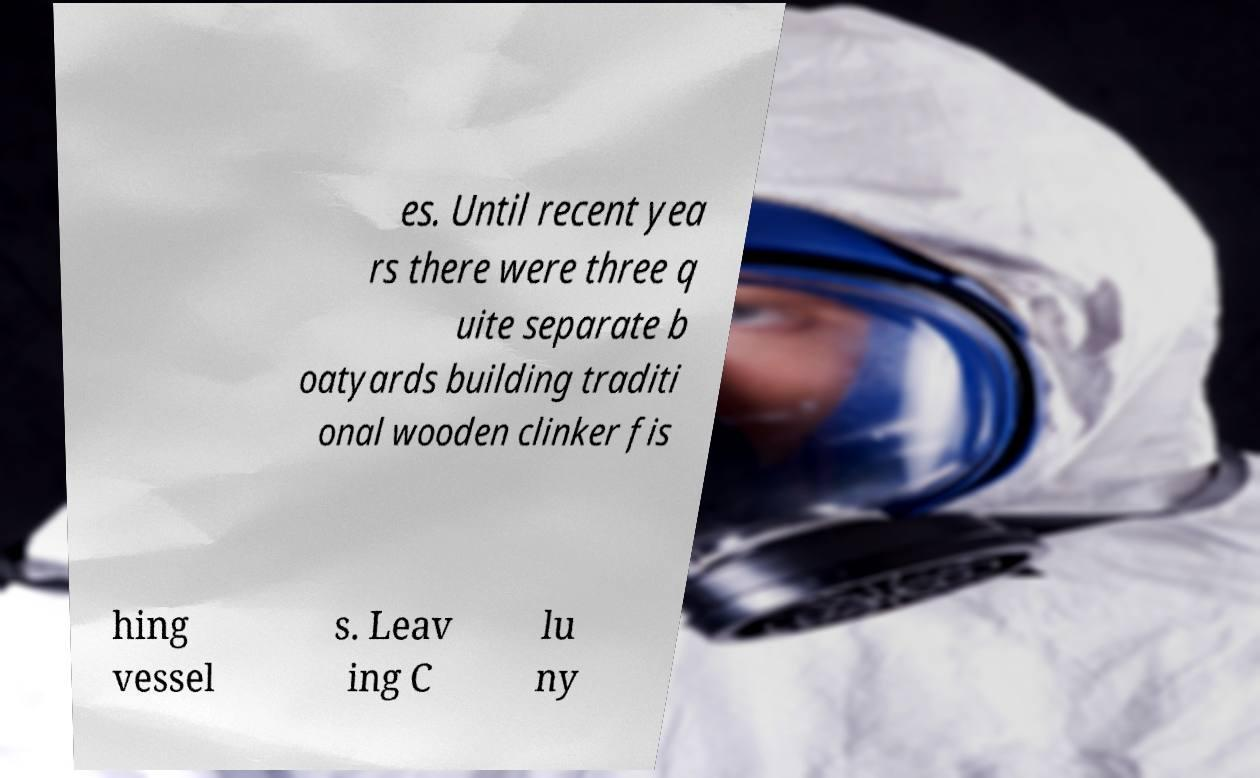Can you read and provide the text displayed in the image?This photo seems to have some interesting text. Can you extract and type it out for me? es. Until recent yea rs there were three q uite separate b oatyards building traditi onal wooden clinker fis hing vessel s. Leav ing C lu ny 